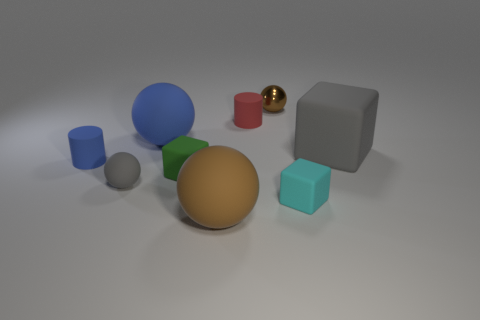What number of yellow cubes are there?
Offer a terse response. 0. Is the material of the tiny green thing the same as the brown sphere that is behind the tiny blue thing?
Keep it short and to the point. No. Do the small sphere that is in front of the metallic object and the metal ball have the same color?
Make the answer very short. No. There is a object that is on the left side of the big blue thing and on the right side of the small blue object; what material is it?
Keep it short and to the point. Rubber. What is the size of the brown metallic object?
Ensure brevity in your answer.  Small. Does the tiny metallic object have the same color as the large rubber sphere that is behind the small green rubber cube?
Your response must be concise. No. How many other objects are the same color as the tiny matte sphere?
Offer a terse response. 1. Do the gray thing that is to the right of the large brown sphere and the cylinder that is on the right side of the tiny blue cylinder have the same size?
Ensure brevity in your answer.  No. What is the color of the tiny block on the right side of the brown metal ball?
Make the answer very short. Cyan. Are there fewer brown metal spheres right of the big brown matte ball than tiny red things?
Provide a short and direct response. No. 